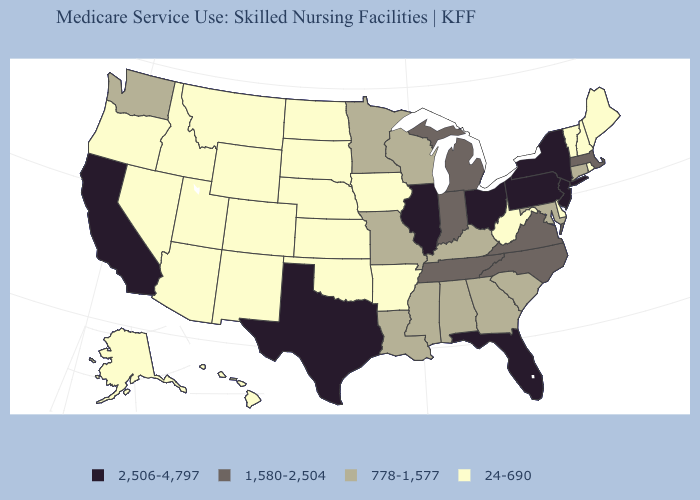What is the lowest value in states that border New Hampshire?
Concise answer only. 24-690. Does California have the highest value in the West?
Concise answer only. Yes. Is the legend a continuous bar?
Concise answer only. No. What is the value of Florida?
Be succinct. 2,506-4,797. What is the value of Alaska?
Write a very short answer. 24-690. Does the map have missing data?
Give a very brief answer. No. What is the lowest value in the USA?
Write a very short answer. 24-690. What is the lowest value in the South?
Write a very short answer. 24-690. Among the states that border Mississippi , which have the highest value?
Keep it brief. Tennessee. What is the lowest value in states that border Iowa?
Keep it brief. 24-690. What is the value of Arizona?
Write a very short answer. 24-690. How many symbols are there in the legend?
Keep it brief. 4. What is the lowest value in the South?
Answer briefly. 24-690. Which states have the lowest value in the USA?
Give a very brief answer. Alaska, Arizona, Arkansas, Colorado, Delaware, Hawaii, Idaho, Iowa, Kansas, Maine, Montana, Nebraska, Nevada, New Hampshire, New Mexico, North Dakota, Oklahoma, Oregon, Rhode Island, South Dakota, Utah, Vermont, West Virginia, Wyoming. Which states have the lowest value in the USA?
Keep it brief. Alaska, Arizona, Arkansas, Colorado, Delaware, Hawaii, Idaho, Iowa, Kansas, Maine, Montana, Nebraska, Nevada, New Hampshire, New Mexico, North Dakota, Oklahoma, Oregon, Rhode Island, South Dakota, Utah, Vermont, West Virginia, Wyoming. 